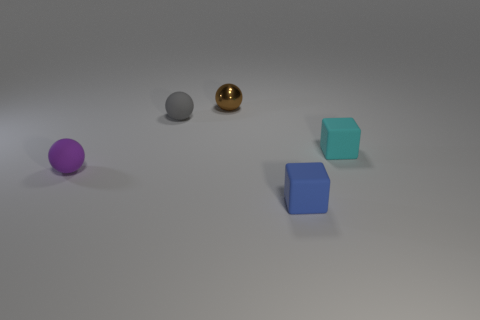Describe the lighting and shadows in the scene. The scene is lit from above, casting gentle shadows below and to the right of each object. The shadows are soft and diffuse, indicating the light source is not extremely intense or focused. Does the lighting help determine the material of the objects? Certainly, the way light reflects and the softness of the shadows hint at the materials. The reflective nature of the spherical objects suggests they are made of some kind of rubber with a shiny finish, while the cubes have a more subdued reflection, typical of a matte finish often associated with harder plastics or painted surfaces. 